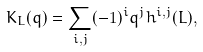<formula> <loc_0><loc_0><loc_500><loc_500>K _ { L } ( q ) = \sum _ { i , j } ( - 1 ) ^ { i } q ^ { j } h ^ { i , j } ( L ) ,</formula> 